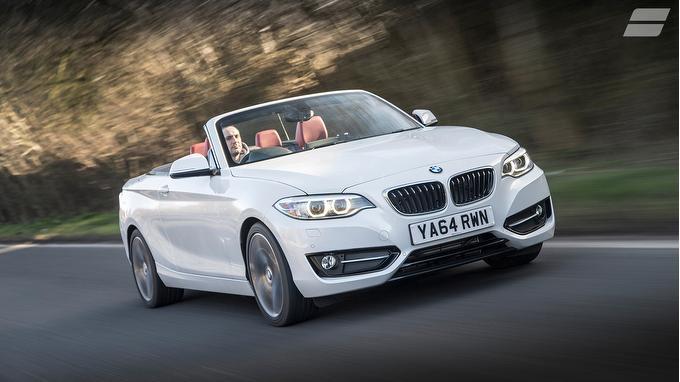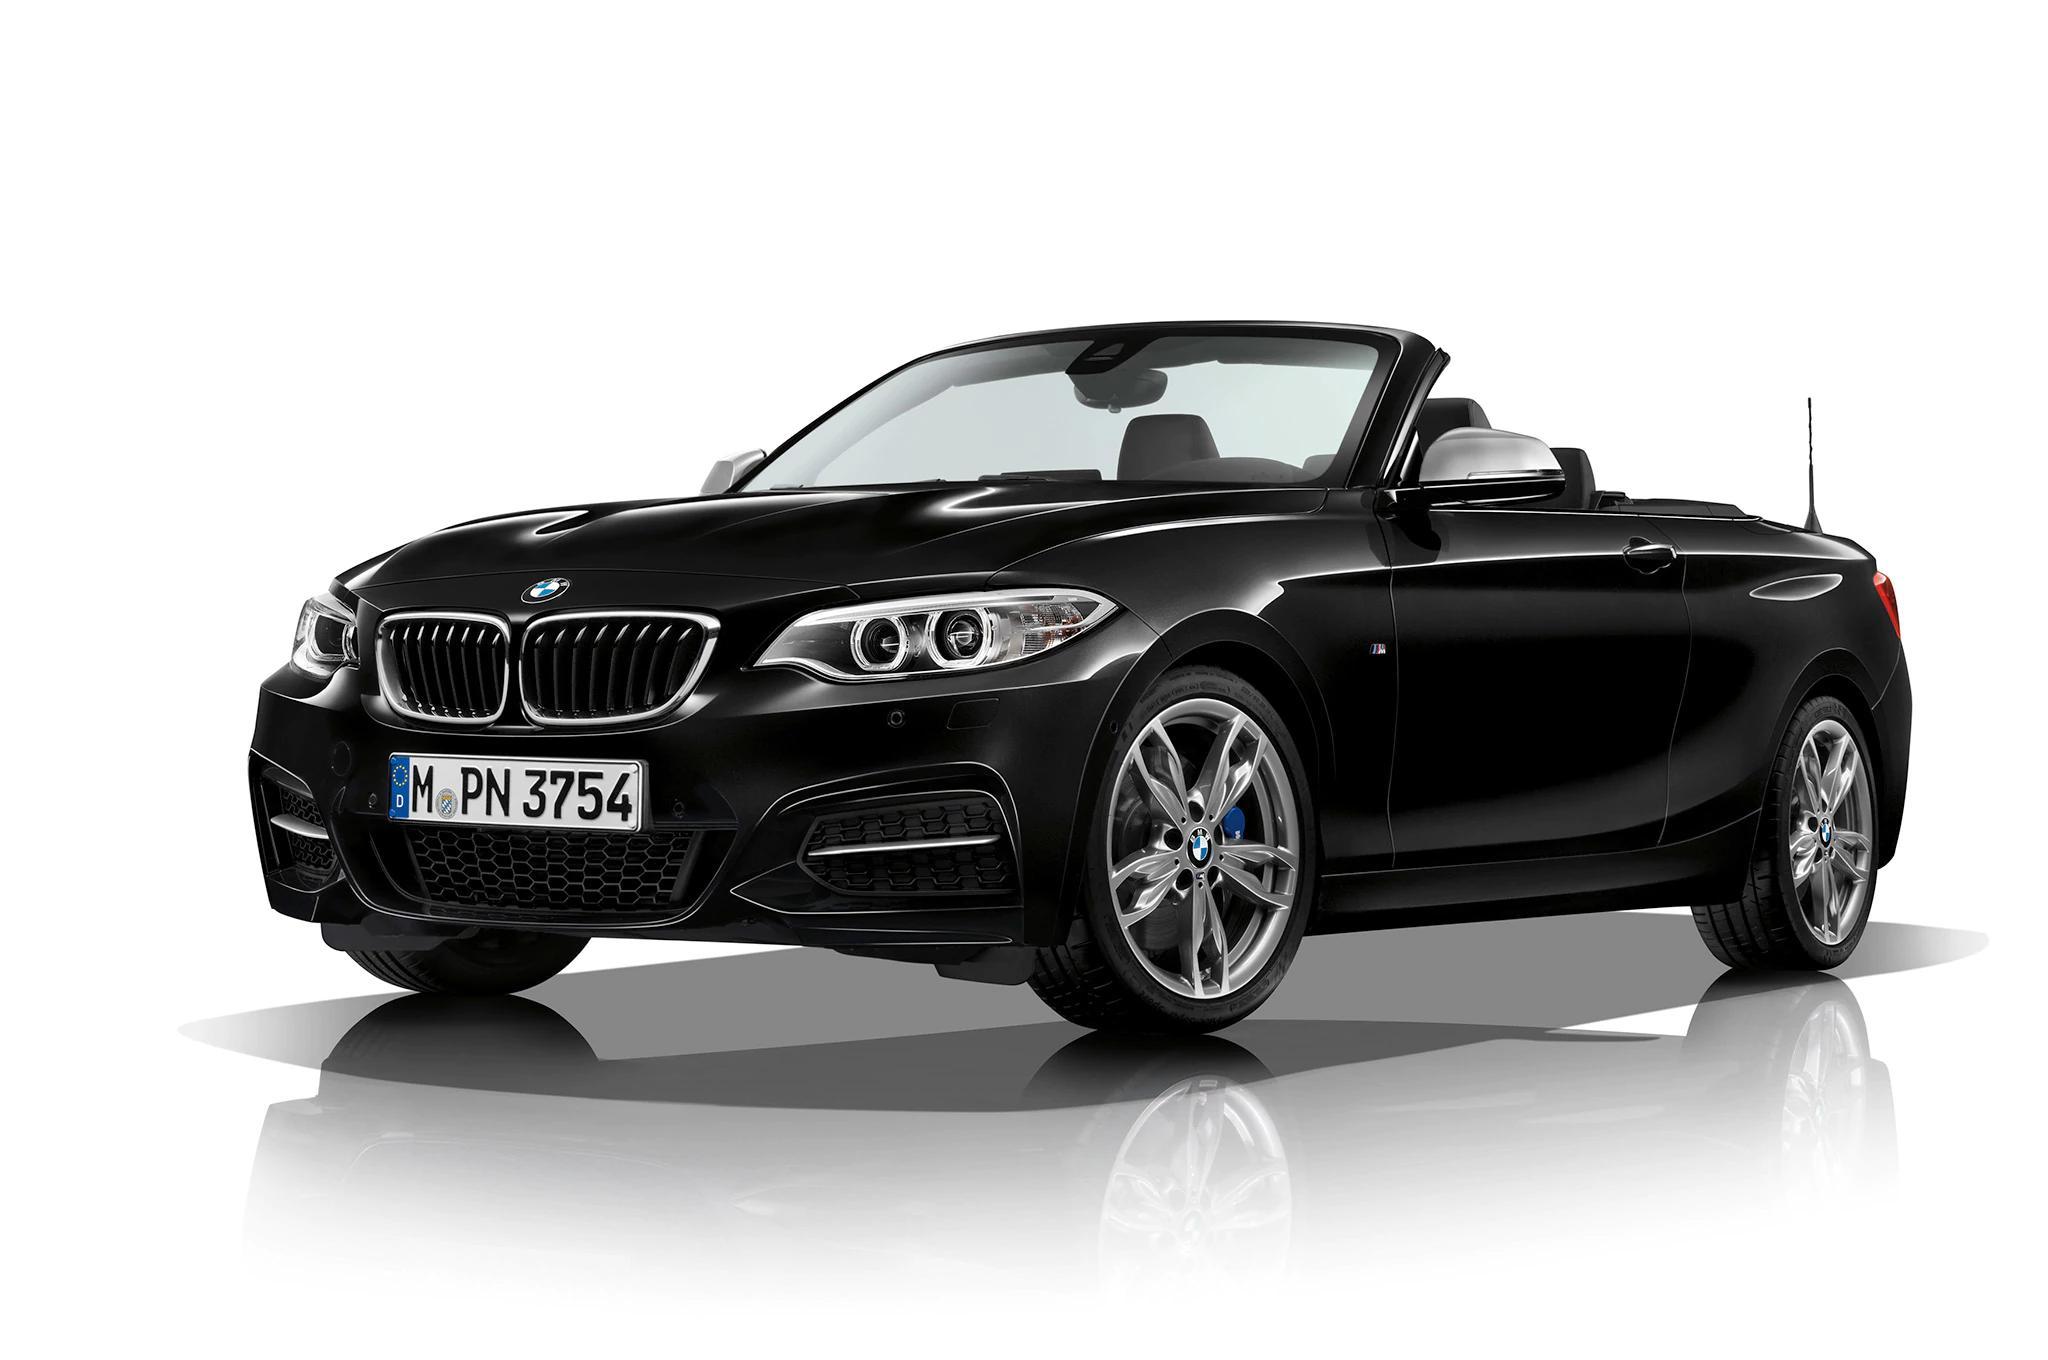The first image is the image on the left, the second image is the image on the right. Examine the images to the left and right. Is the description "One of the cars is black and the rest are white." accurate? Answer yes or no. Yes. The first image is the image on the left, the second image is the image on the right. Considering the images on both sides, is "An image contains exactly one parked white convertible, which has red covered seats." valid? Answer yes or no. No. 